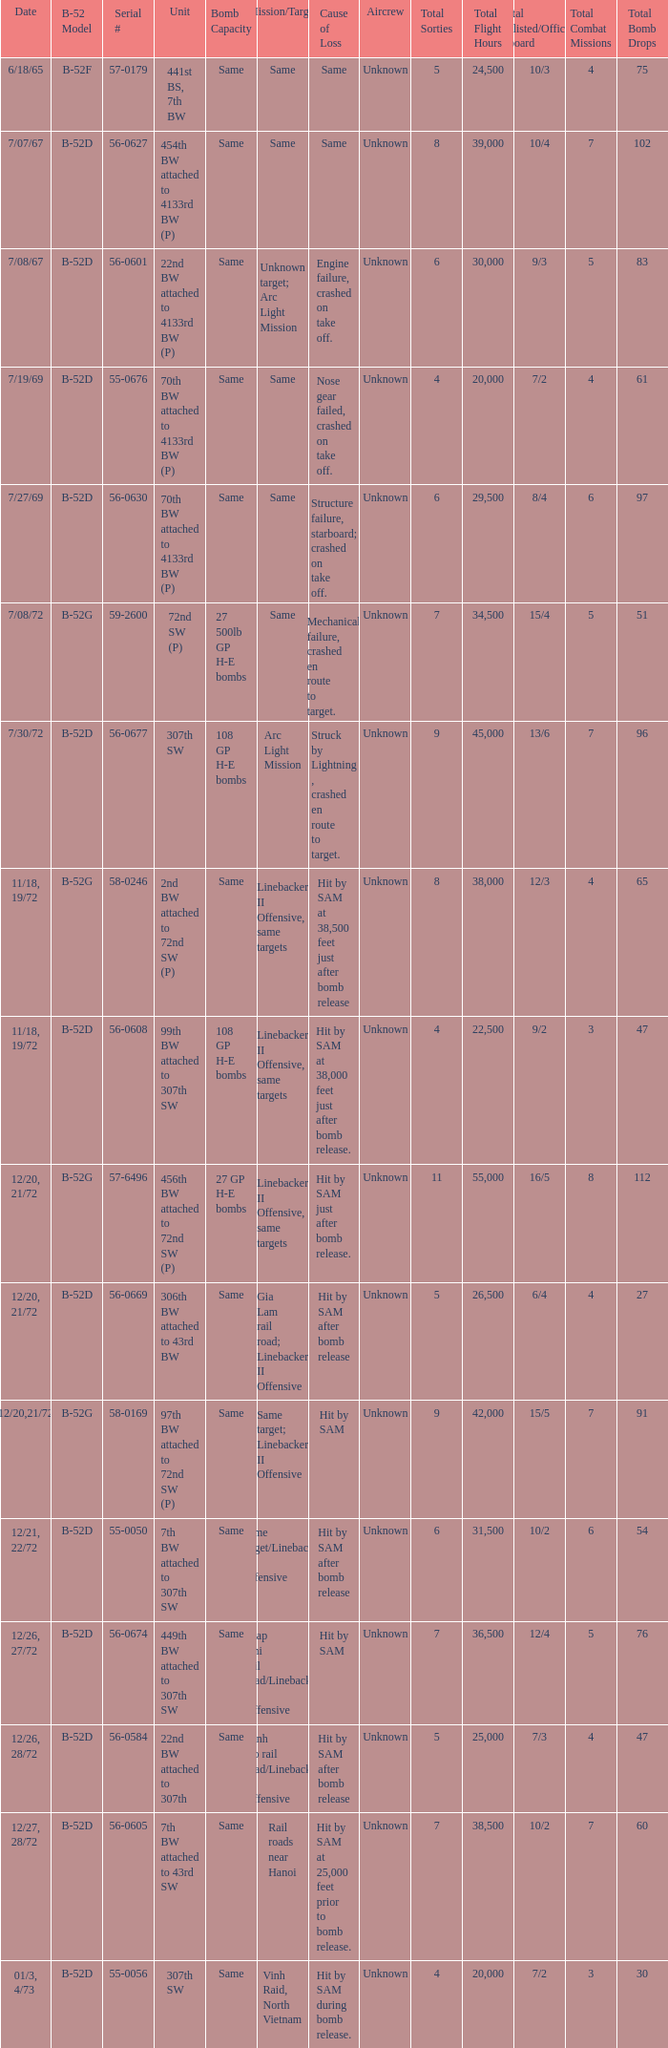When  27 gp h-e bombs the capacity of the bomb what is the cause of loss? Hit by SAM just after bomb release. 